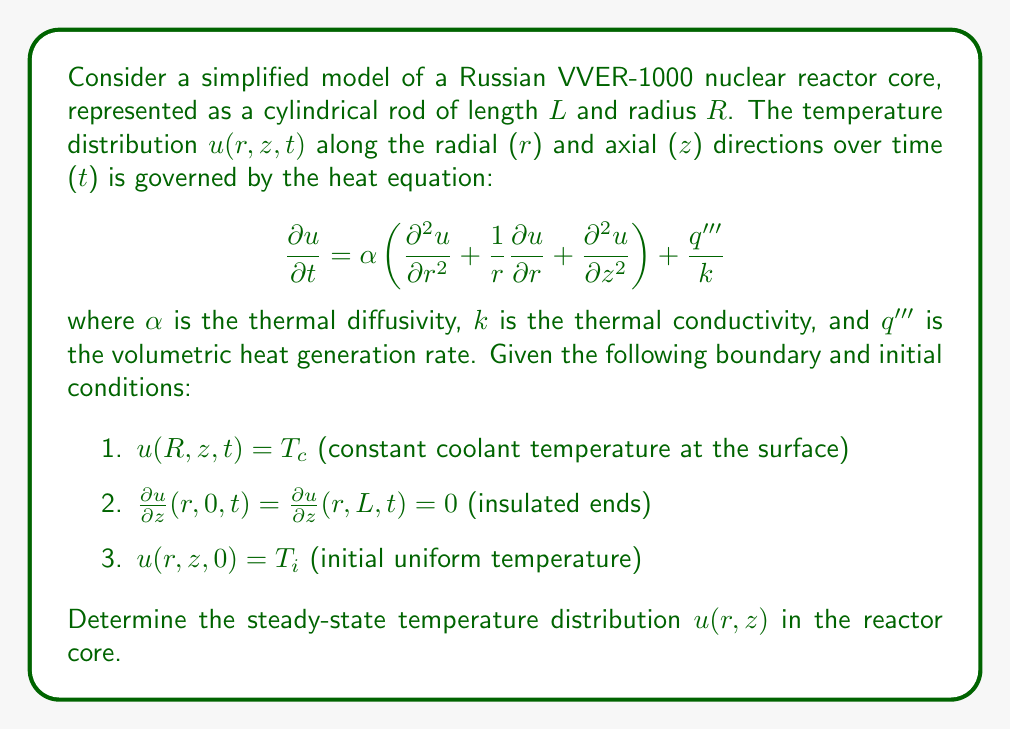Give your solution to this math problem. To solve this problem, we'll follow these steps:

1) For steady-state conditions, $\frac{\partial u}{\partial t} = 0$. The heat equation becomes:

   $$0 = \alpha \left(\frac{\partial^2 u}{\partial r^2} + \frac{1}{r}\frac{\partial u}{\partial r} + \frac{\partial^2 u}{\partial z^2}\right) + \frac{q'''}{k}$$

2) Due to the insulated ends, we can assume that the temperature doesn't depend on $z$. This simplifies our equation to:

   $$\frac{d^2 u}{dr^2} + \frac{1}{r}\frac{du}{dr} = -\frac{q'''}{k\alpha}$$

3) Let $\frac{q'''}{k\alpha} = C$ (constant). Our equation is now:

   $$\frac{d^2 u}{dr^2} + \frac{1}{r}\frac{du}{dr} = -C$$

4) This is a non-homogeneous Bessel equation. The general solution is:

   $$u(r) = A + B \ln(r) - \frac{C}{4}r^2$$

   where $A$ and $B$ are constants to be determined.

5) Apply the boundary condition at $r = R$:

   $$T_c = A + B \ln(R) - \frac{C}{4}R^2$$

6) For the solution to be finite at $r = 0$, we must have $B = 0$. Thus:

   $$u(r) = A - \frac{C}{4}r^2$$

7) Solve for $A$ using the boundary condition:

   $$A = T_c + \frac{C}{4}R^2$$

8) Therefore, the final steady-state temperature distribution is:

   $$u(r) = T_c + \frac{q'''}{4k\alpha}(R^2 - r^2)$$

This solution represents a parabolic temperature profile with the maximum temperature at the center of the rod.
Answer: $$u(r) = T_c + \frac{q'''}{4k\alpha}(R^2 - r^2)$$ 